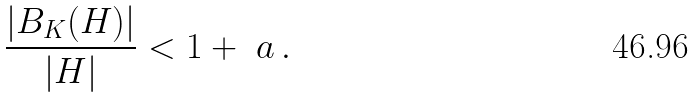Convert formula to latex. <formula><loc_0><loc_0><loc_500><loc_500>\frac { | B _ { K } ( H ) | } { | H | } < 1 + \ a \, .</formula> 